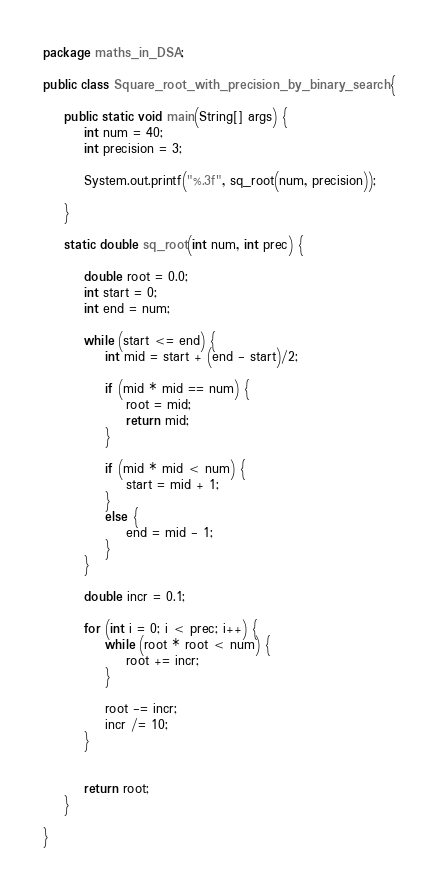<code> <loc_0><loc_0><loc_500><loc_500><_Java_>package maths_in_DSA;

public class Square_root_with_precision_by_binary_search {

	public static void main(String[] args) {
		int num = 40;
		int precision = 3;
		
		System.out.printf("%.3f", sq_root(num, precision));

	}
	
	static double sq_root(int num, int prec) {
		
		double root = 0.0;
		int start = 0;
		int end = num;
		
		while (start <= end) {
			int mid = start + (end - start)/2;
			
			if (mid * mid == num) {
				root = mid;
				return mid;
			}
			
			if (mid * mid < num) {
				start = mid + 1;
			}
			else {
				end = mid - 1;
			}
		}
		
		double incr = 0.1;
		
		for (int i = 0; i < prec; i++) {
			while (root * root < num) {
				root += incr;
			}
			
			root -= incr;
			incr /= 10;
		}
		
		
		return root;
	}

}
</code> 